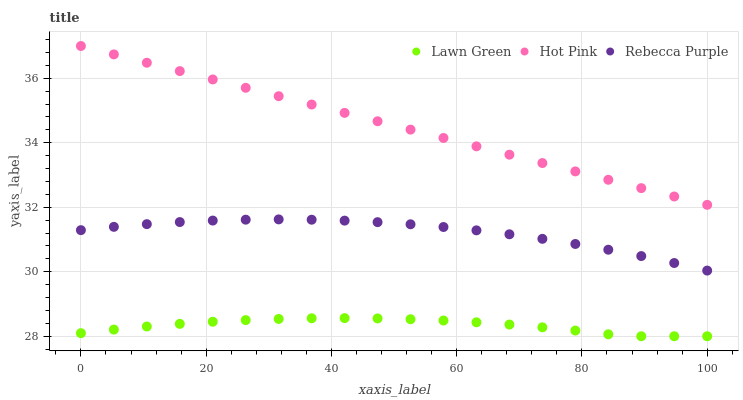Does Lawn Green have the minimum area under the curve?
Answer yes or no. Yes. Does Hot Pink have the maximum area under the curve?
Answer yes or no. Yes. Does Rebecca Purple have the minimum area under the curve?
Answer yes or no. No. Does Rebecca Purple have the maximum area under the curve?
Answer yes or no. No. Is Hot Pink the smoothest?
Answer yes or no. Yes. Is Lawn Green the roughest?
Answer yes or no. Yes. Is Rebecca Purple the smoothest?
Answer yes or no. No. Is Rebecca Purple the roughest?
Answer yes or no. No. Does Lawn Green have the lowest value?
Answer yes or no. Yes. Does Rebecca Purple have the lowest value?
Answer yes or no. No. Does Hot Pink have the highest value?
Answer yes or no. Yes. Does Rebecca Purple have the highest value?
Answer yes or no. No. Is Rebecca Purple less than Hot Pink?
Answer yes or no. Yes. Is Hot Pink greater than Lawn Green?
Answer yes or no. Yes. Does Rebecca Purple intersect Hot Pink?
Answer yes or no. No. 